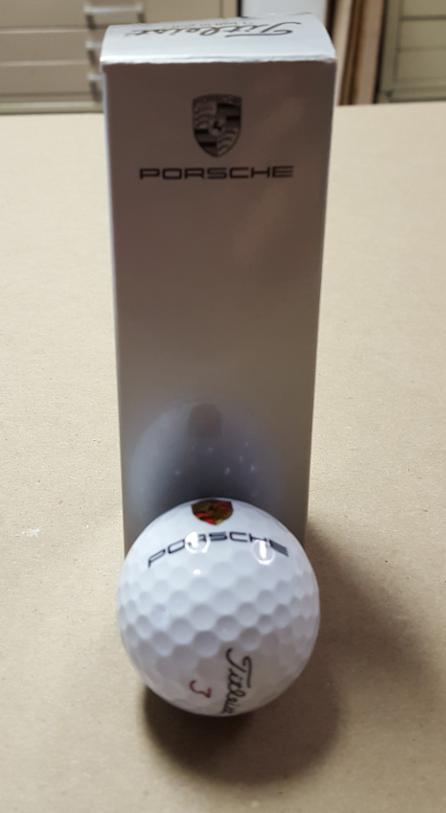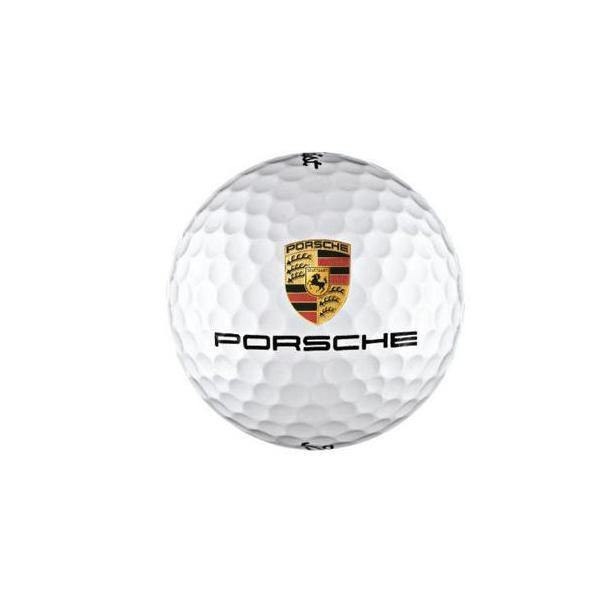The first image is the image on the left, the second image is the image on the right. Assess this claim about the two images: "An image shows a group of exactly three white golf balls with the same logos printed on them.". Correct or not? Answer yes or no. No. The first image is the image on the left, the second image is the image on the right. Considering the images on both sides, is "The right image contains at least three golf balls." valid? Answer yes or no. No. 